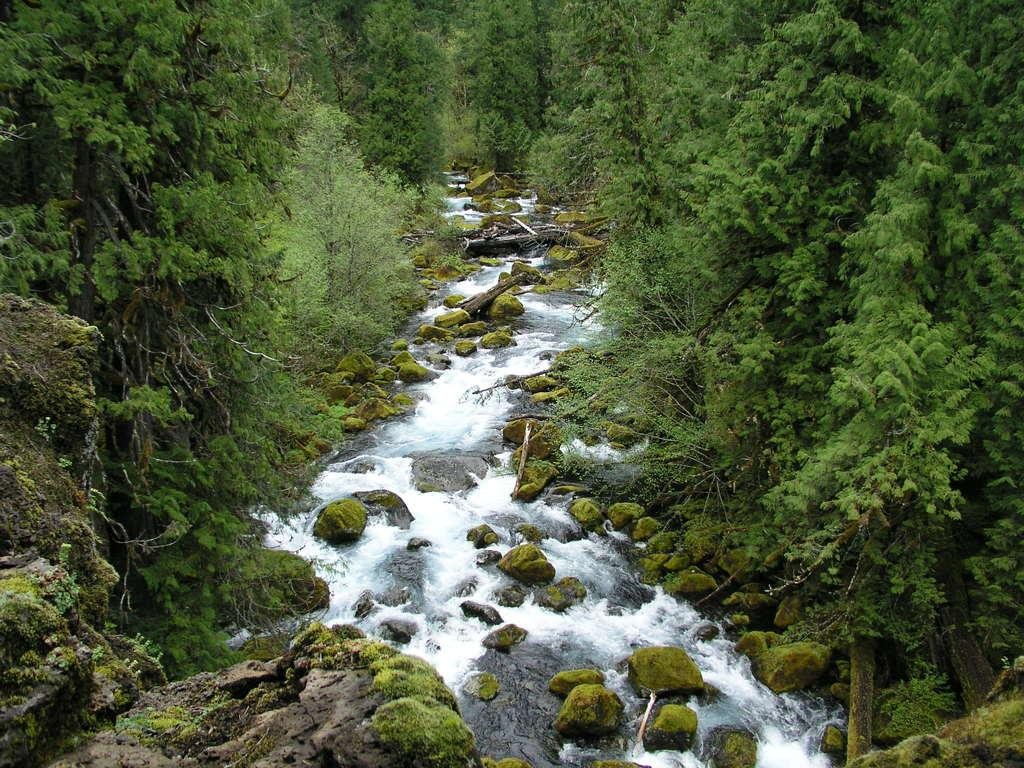What is the main feature of the image? The main feature of the image is a water flow. Are there any other elements present in the image besides the water flow? Yes, there are trees beside the water flow in the image. What type of honey can be seen dripping from the trees in the image? There is no honey present in the image; it features a water flow and trees. 